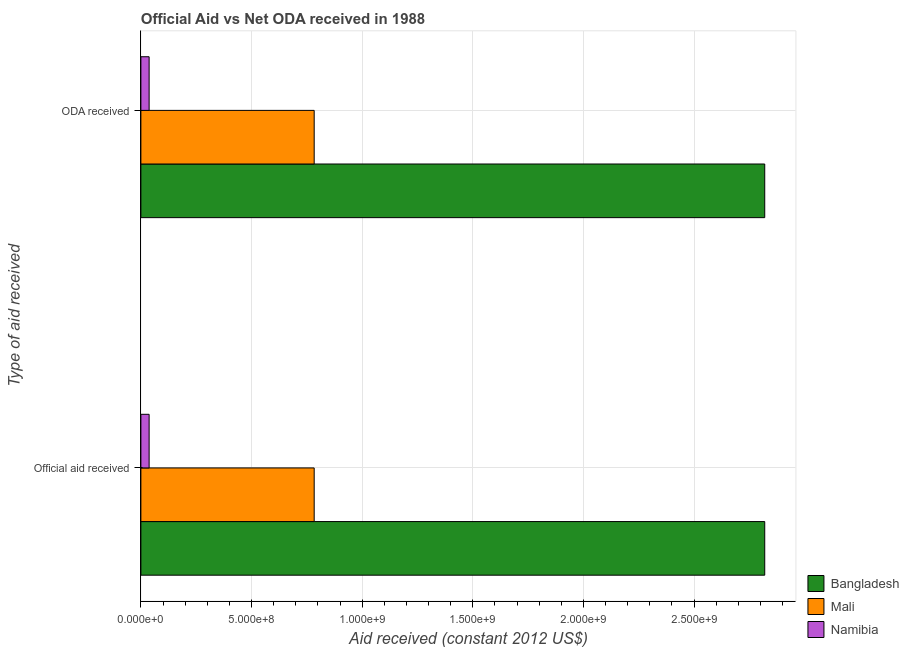How many different coloured bars are there?
Your answer should be compact. 3. How many groups of bars are there?
Provide a succinct answer. 2. Are the number of bars on each tick of the Y-axis equal?
Your answer should be compact. Yes. What is the label of the 1st group of bars from the top?
Your answer should be very brief. ODA received. What is the oda received in Mali?
Provide a short and direct response. 7.83e+08. Across all countries, what is the maximum oda received?
Provide a short and direct response. 2.82e+09. Across all countries, what is the minimum oda received?
Your answer should be compact. 3.72e+07. In which country was the official aid received minimum?
Make the answer very short. Namibia. What is the total oda received in the graph?
Your answer should be compact. 3.64e+09. What is the difference between the official aid received in Bangladesh and that in Mali?
Your answer should be compact. 2.04e+09. What is the difference between the oda received in Mali and the official aid received in Bangladesh?
Keep it short and to the point. -2.04e+09. What is the average official aid received per country?
Your answer should be very brief. 1.21e+09. In how many countries, is the oda received greater than 1900000000 US$?
Provide a short and direct response. 1. What is the ratio of the official aid received in Namibia to that in Bangladesh?
Make the answer very short. 0.01. In how many countries, is the official aid received greater than the average official aid received taken over all countries?
Your answer should be compact. 1. What does the 2nd bar from the top in Official aid received represents?
Give a very brief answer. Mali. How many countries are there in the graph?
Make the answer very short. 3. Are the values on the major ticks of X-axis written in scientific E-notation?
Make the answer very short. Yes. Does the graph contain any zero values?
Offer a very short reply. No. Does the graph contain grids?
Ensure brevity in your answer.  Yes. How many legend labels are there?
Offer a very short reply. 3. What is the title of the graph?
Your answer should be very brief. Official Aid vs Net ODA received in 1988 . What is the label or title of the X-axis?
Keep it short and to the point. Aid received (constant 2012 US$). What is the label or title of the Y-axis?
Offer a very short reply. Type of aid received. What is the Aid received (constant 2012 US$) of Bangladesh in Official aid received?
Give a very brief answer. 2.82e+09. What is the Aid received (constant 2012 US$) of Mali in Official aid received?
Provide a succinct answer. 7.83e+08. What is the Aid received (constant 2012 US$) of Namibia in Official aid received?
Offer a terse response. 3.72e+07. What is the Aid received (constant 2012 US$) of Bangladesh in ODA received?
Offer a terse response. 2.82e+09. What is the Aid received (constant 2012 US$) in Mali in ODA received?
Offer a terse response. 7.83e+08. What is the Aid received (constant 2012 US$) in Namibia in ODA received?
Provide a succinct answer. 3.72e+07. Across all Type of aid received, what is the maximum Aid received (constant 2012 US$) of Bangladesh?
Provide a succinct answer. 2.82e+09. Across all Type of aid received, what is the maximum Aid received (constant 2012 US$) of Mali?
Make the answer very short. 7.83e+08. Across all Type of aid received, what is the maximum Aid received (constant 2012 US$) of Namibia?
Provide a succinct answer. 3.72e+07. Across all Type of aid received, what is the minimum Aid received (constant 2012 US$) in Bangladesh?
Provide a short and direct response. 2.82e+09. Across all Type of aid received, what is the minimum Aid received (constant 2012 US$) of Mali?
Offer a very short reply. 7.83e+08. Across all Type of aid received, what is the minimum Aid received (constant 2012 US$) in Namibia?
Your answer should be compact. 3.72e+07. What is the total Aid received (constant 2012 US$) of Bangladesh in the graph?
Provide a short and direct response. 5.64e+09. What is the total Aid received (constant 2012 US$) in Mali in the graph?
Provide a short and direct response. 1.57e+09. What is the total Aid received (constant 2012 US$) of Namibia in the graph?
Provide a succinct answer. 7.44e+07. What is the difference between the Aid received (constant 2012 US$) in Namibia in Official aid received and that in ODA received?
Your response must be concise. 0. What is the difference between the Aid received (constant 2012 US$) in Bangladesh in Official aid received and the Aid received (constant 2012 US$) in Mali in ODA received?
Keep it short and to the point. 2.04e+09. What is the difference between the Aid received (constant 2012 US$) in Bangladesh in Official aid received and the Aid received (constant 2012 US$) in Namibia in ODA received?
Keep it short and to the point. 2.78e+09. What is the difference between the Aid received (constant 2012 US$) in Mali in Official aid received and the Aid received (constant 2012 US$) in Namibia in ODA received?
Provide a succinct answer. 7.46e+08. What is the average Aid received (constant 2012 US$) of Bangladesh per Type of aid received?
Your answer should be compact. 2.82e+09. What is the average Aid received (constant 2012 US$) of Mali per Type of aid received?
Your answer should be very brief. 7.83e+08. What is the average Aid received (constant 2012 US$) of Namibia per Type of aid received?
Your answer should be very brief. 3.72e+07. What is the difference between the Aid received (constant 2012 US$) in Bangladesh and Aid received (constant 2012 US$) in Mali in Official aid received?
Your answer should be compact. 2.04e+09. What is the difference between the Aid received (constant 2012 US$) of Bangladesh and Aid received (constant 2012 US$) of Namibia in Official aid received?
Offer a terse response. 2.78e+09. What is the difference between the Aid received (constant 2012 US$) of Mali and Aid received (constant 2012 US$) of Namibia in Official aid received?
Offer a terse response. 7.46e+08. What is the difference between the Aid received (constant 2012 US$) in Bangladesh and Aid received (constant 2012 US$) in Mali in ODA received?
Offer a terse response. 2.04e+09. What is the difference between the Aid received (constant 2012 US$) in Bangladesh and Aid received (constant 2012 US$) in Namibia in ODA received?
Offer a very short reply. 2.78e+09. What is the difference between the Aid received (constant 2012 US$) in Mali and Aid received (constant 2012 US$) in Namibia in ODA received?
Provide a succinct answer. 7.46e+08. What is the ratio of the Aid received (constant 2012 US$) of Bangladesh in Official aid received to that in ODA received?
Your answer should be compact. 1. What is the difference between the highest and the lowest Aid received (constant 2012 US$) of Bangladesh?
Offer a very short reply. 0. What is the difference between the highest and the lowest Aid received (constant 2012 US$) in Mali?
Make the answer very short. 0. 